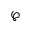<formula> <loc_0><loc_0><loc_500><loc_500>\wp</formula> 